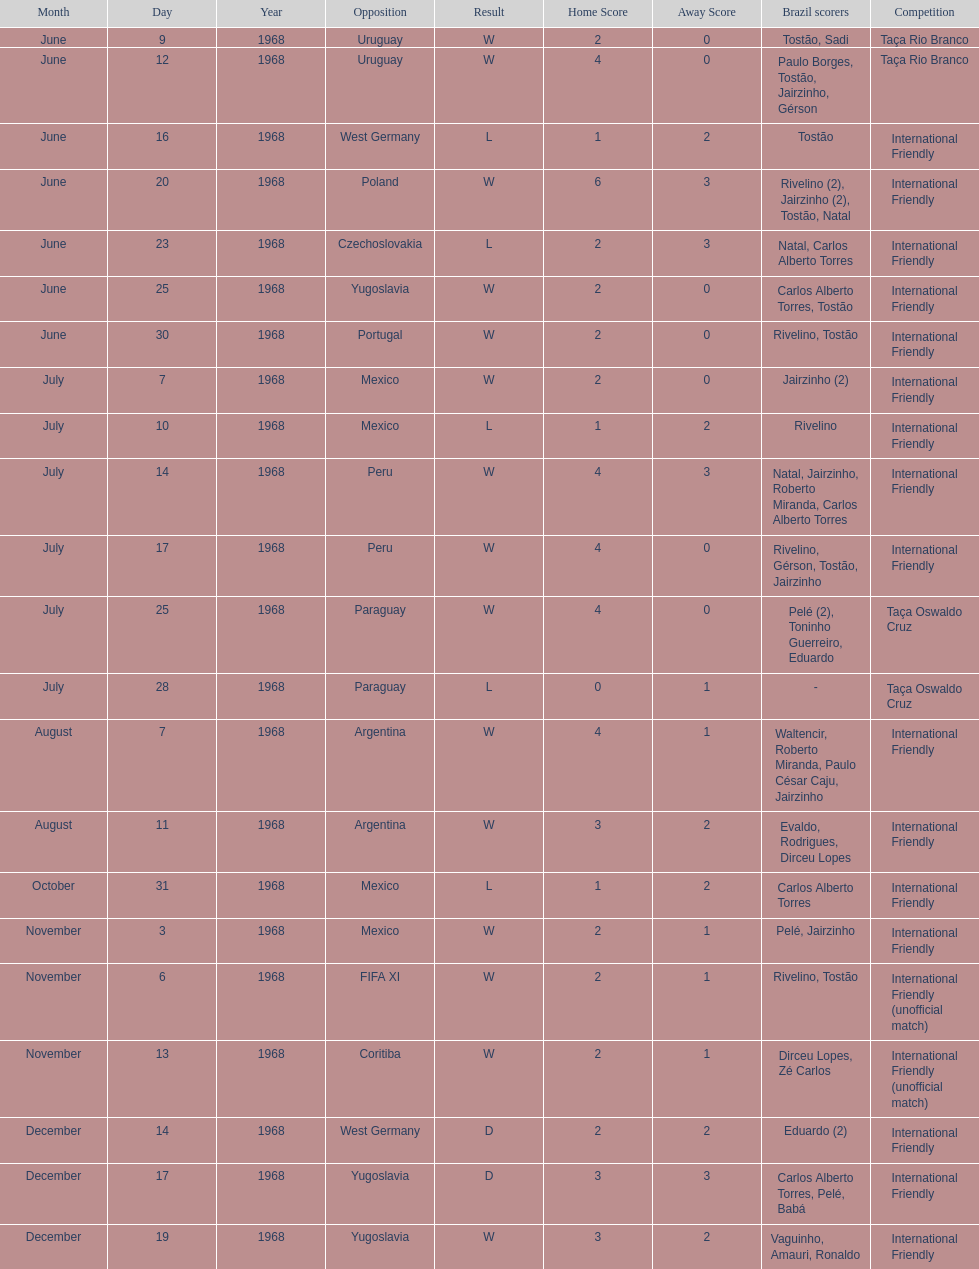How many times did brazil score during the game on november 6th? 2. 